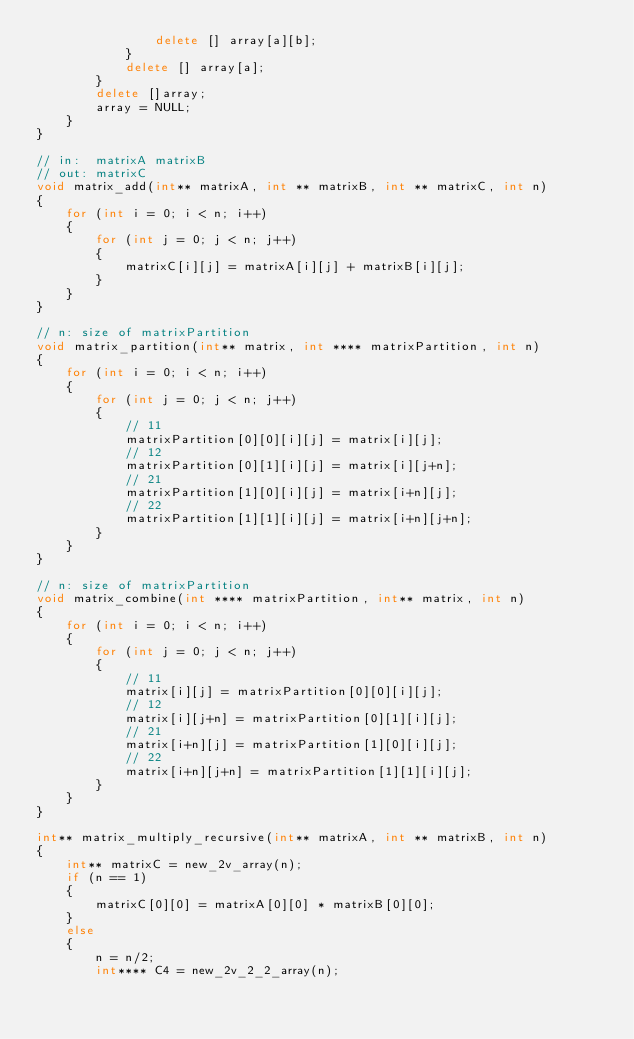<code> <loc_0><loc_0><loc_500><loc_500><_C++_>                delete [] array[a][b];
            }
            delete [] array[a];
        }
        delete []array;
        array = NULL;
    }
}

// in:  matrixA matrixB
// out: matrixC
void matrix_add(int** matrixA, int ** matrixB, int ** matrixC, int n)
{
    for (int i = 0; i < n; i++)
    {
        for (int j = 0; j < n; j++)
        {
            matrixC[i][j] = matrixA[i][j] + matrixB[i][j];
        }
    }
}

// n: size of matrixPartition
void matrix_partition(int** matrix, int **** matrixPartition, int n)
{
    for (int i = 0; i < n; i++)
    {
        for (int j = 0; j < n; j++)
        {
            // 11
            matrixPartition[0][0][i][j] = matrix[i][j];
            // 12
            matrixPartition[0][1][i][j] = matrix[i][j+n];
            // 21
            matrixPartition[1][0][i][j] = matrix[i+n][j];
            // 22
            matrixPartition[1][1][i][j] = matrix[i+n][j+n];
        }
    }
}

// n: size of matrixPartition
void matrix_combine(int **** matrixPartition, int** matrix, int n)
{
    for (int i = 0; i < n; i++)
    {
        for (int j = 0; j < n; j++)
        {
            // 11
            matrix[i][j] = matrixPartition[0][0][i][j];
            // 12
            matrix[i][j+n] = matrixPartition[0][1][i][j];
            // 21
            matrix[i+n][j] = matrixPartition[1][0][i][j];
            // 22
            matrix[i+n][j+n] = matrixPartition[1][1][i][j];
        }
    }
}

int** matrix_multiply_recursive(int** matrixA, int ** matrixB, int n)
{
    int** matrixC = new_2v_array(n);
    if (n == 1)
    {
        matrixC[0][0] = matrixA[0][0] * matrixB[0][0];
    }
    else
    {
        n = n/2;
        int**** C4 = new_2v_2_2_array(n);
</code> 